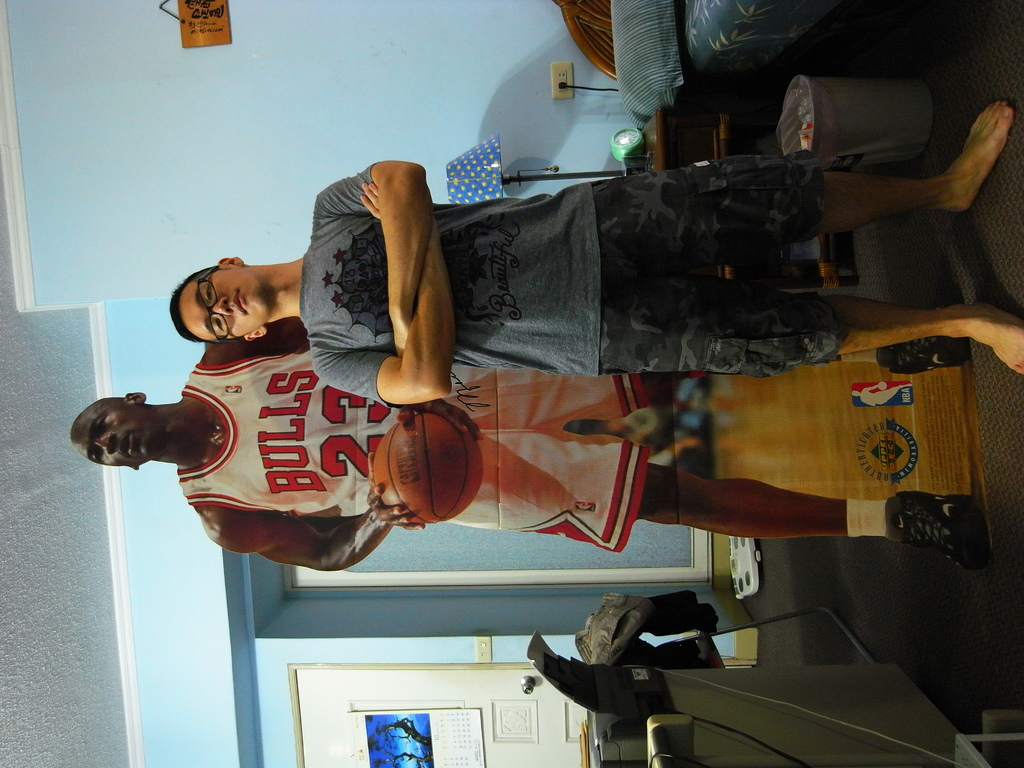What is unique about the room decoration in this image? The room features a large, life-size poster of Michael Jordan, which not only adds a striking visual element but also highlights the resident's admiration for the basketball legend. 